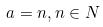Convert formula to latex. <formula><loc_0><loc_0><loc_500><loc_500>a = n , n \in N</formula> 